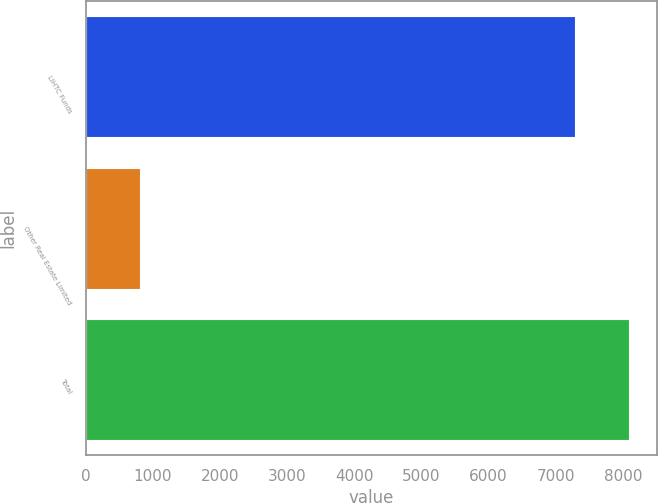Convert chart to OTSL. <chart><loc_0><loc_0><loc_500><loc_500><bar_chart><fcel>LIHTC Funds<fcel>Other Real Estate Limited<fcel>Total<nl><fcel>7292<fcel>804<fcel>8096<nl></chart> 